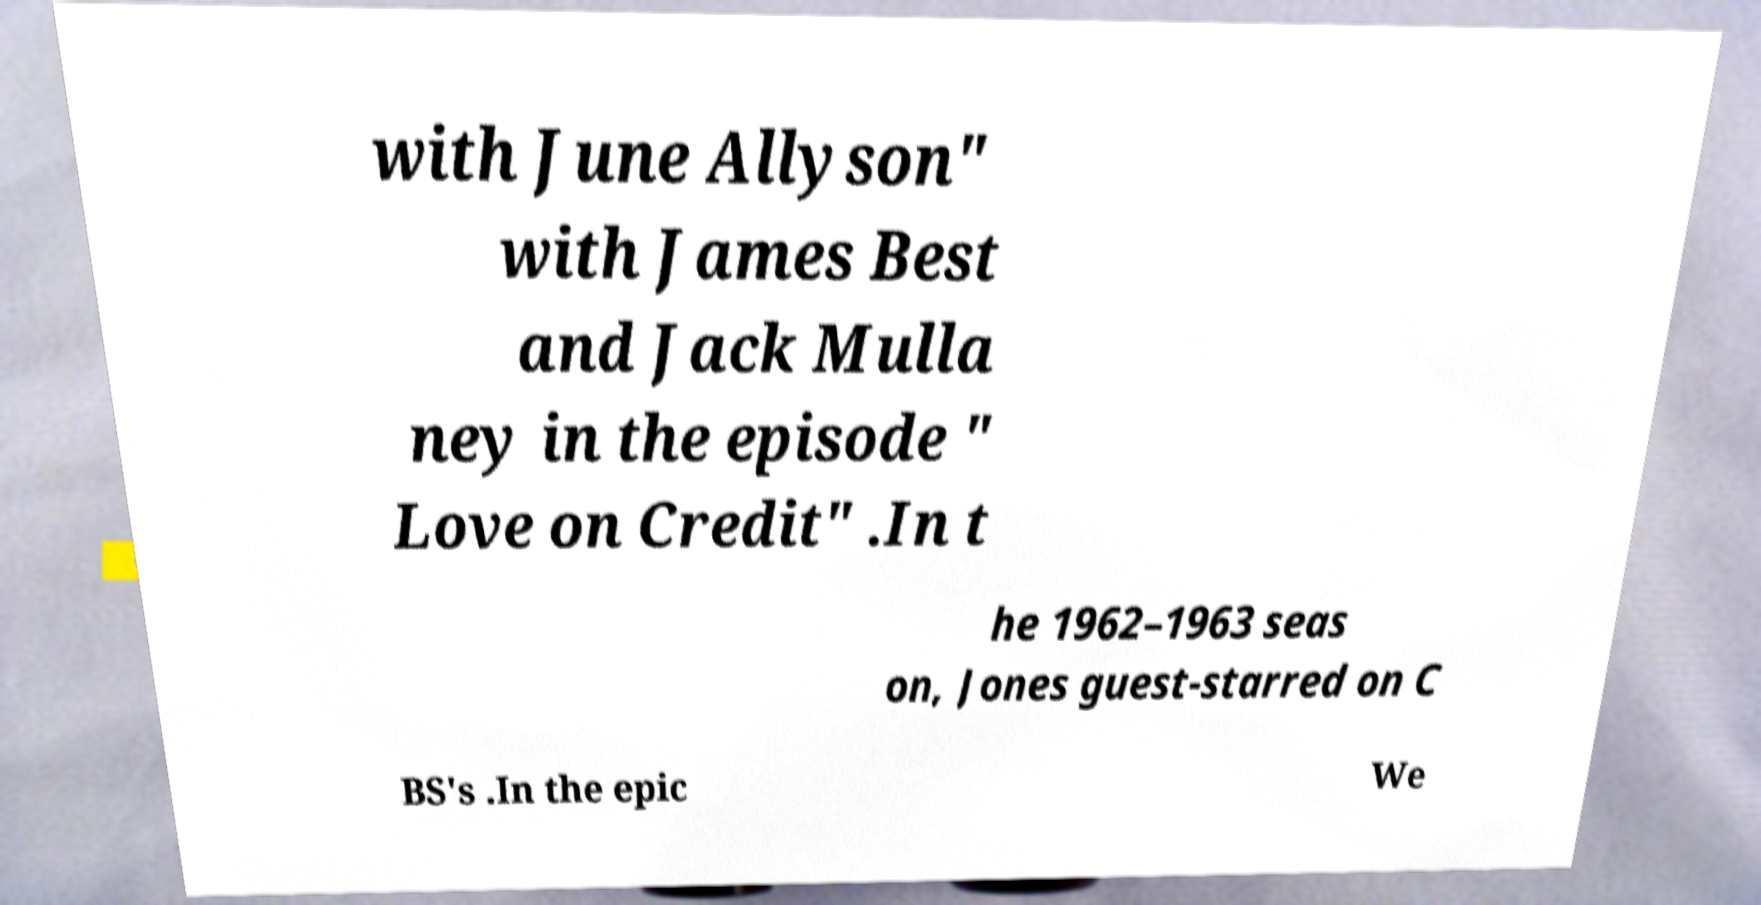Please identify and transcribe the text found in this image. with June Allyson" with James Best and Jack Mulla ney in the episode " Love on Credit" .In t he 1962–1963 seas on, Jones guest-starred on C BS's .In the epic We 